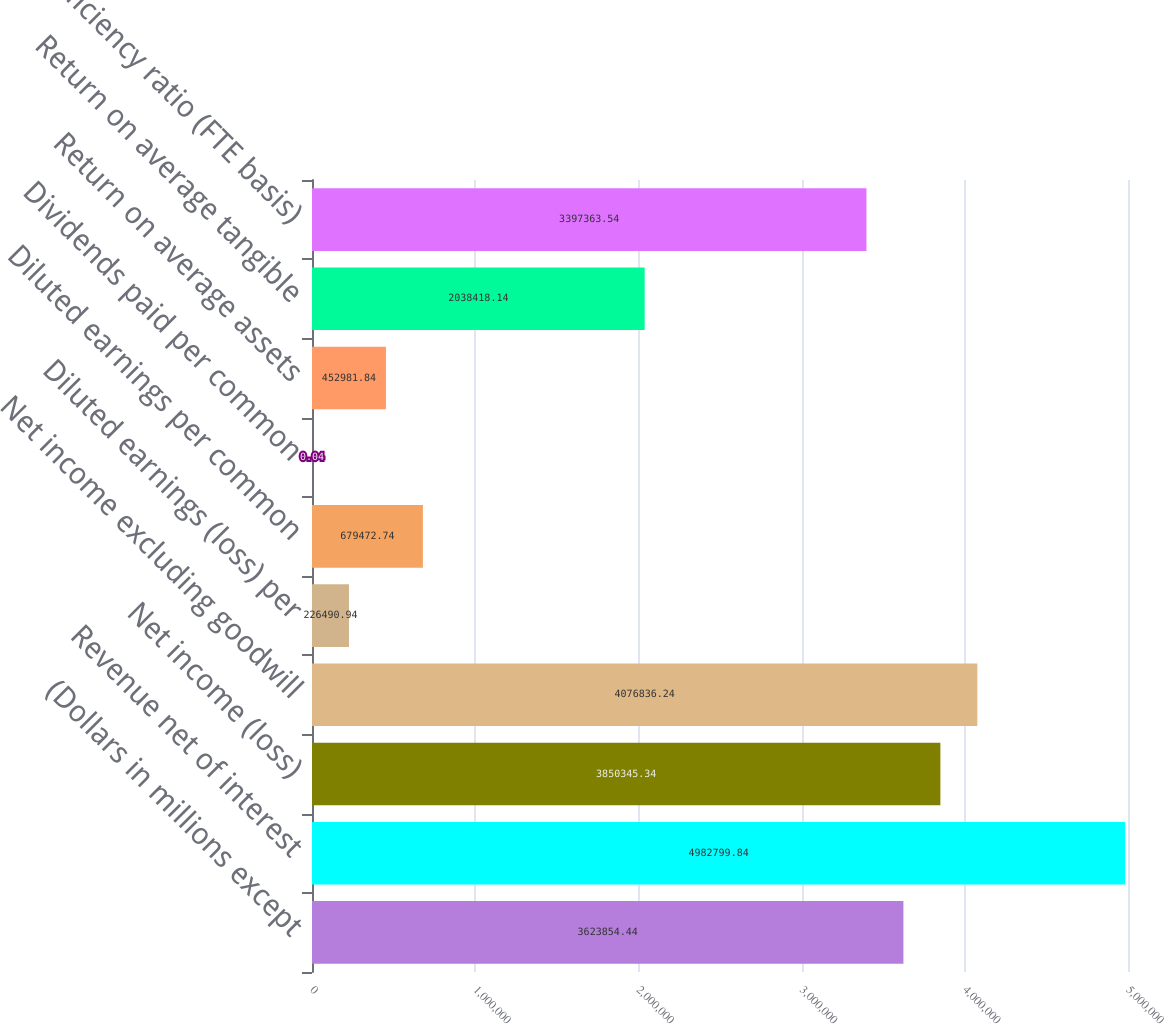Convert chart. <chart><loc_0><loc_0><loc_500><loc_500><bar_chart><fcel>(Dollars in millions except<fcel>Revenue net of interest<fcel>Net income (loss)<fcel>Net income excluding goodwill<fcel>Diluted earnings (loss) per<fcel>Diluted earnings per common<fcel>Dividends paid per common<fcel>Return on average assets<fcel>Return on average tangible<fcel>Efficiency ratio (FTE basis)<nl><fcel>3.62385e+06<fcel>4.9828e+06<fcel>3.85035e+06<fcel>4.07684e+06<fcel>226491<fcel>679473<fcel>0.04<fcel>452982<fcel>2.03842e+06<fcel>3.39736e+06<nl></chart> 